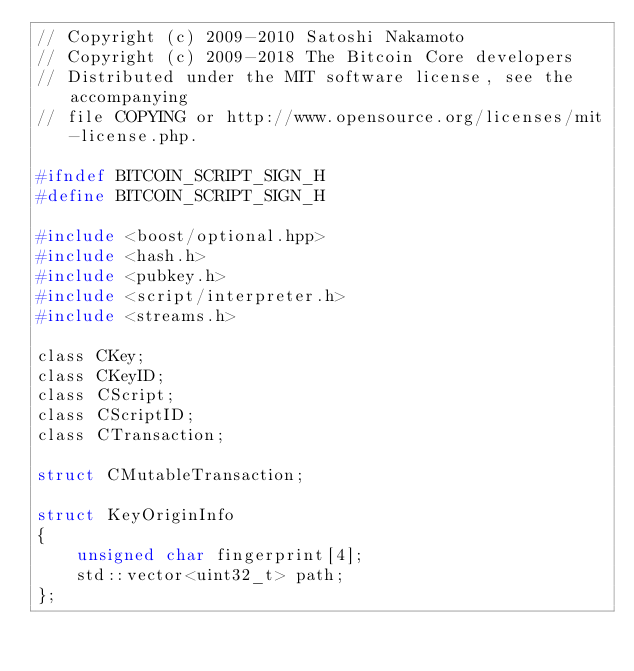Convert code to text. <code><loc_0><loc_0><loc_500><loc_500><_C_>// Copyright (c) 2009-2010 Satoshi Nakamoto
// Copyright (c) 2009-2018 The Bitcoin Core developers
// Distributed under the MIT software license, see the accompanying
// file COPYING or http://www.opensource.org/licenses/mit-license.php.

#ifndef BITCOIN_SCRIPT_SIGN_H
#define BITCOIN_SCRIPT_SIGN_H

#include <boost/optional.hpp>
#include <hash.h>
#include <pubkey.h>
#include <script/interpreter.h>
#include <streams.h>

class CKey;
class CKeyID;
class CScript;
class CScriptID;
class CTransaction;

struct CMutableTransaction;

struct KeyOriginInfo
{
    unsigned char fingerprint[4];
    std::vector<uint32_t> path;
};
</code> 